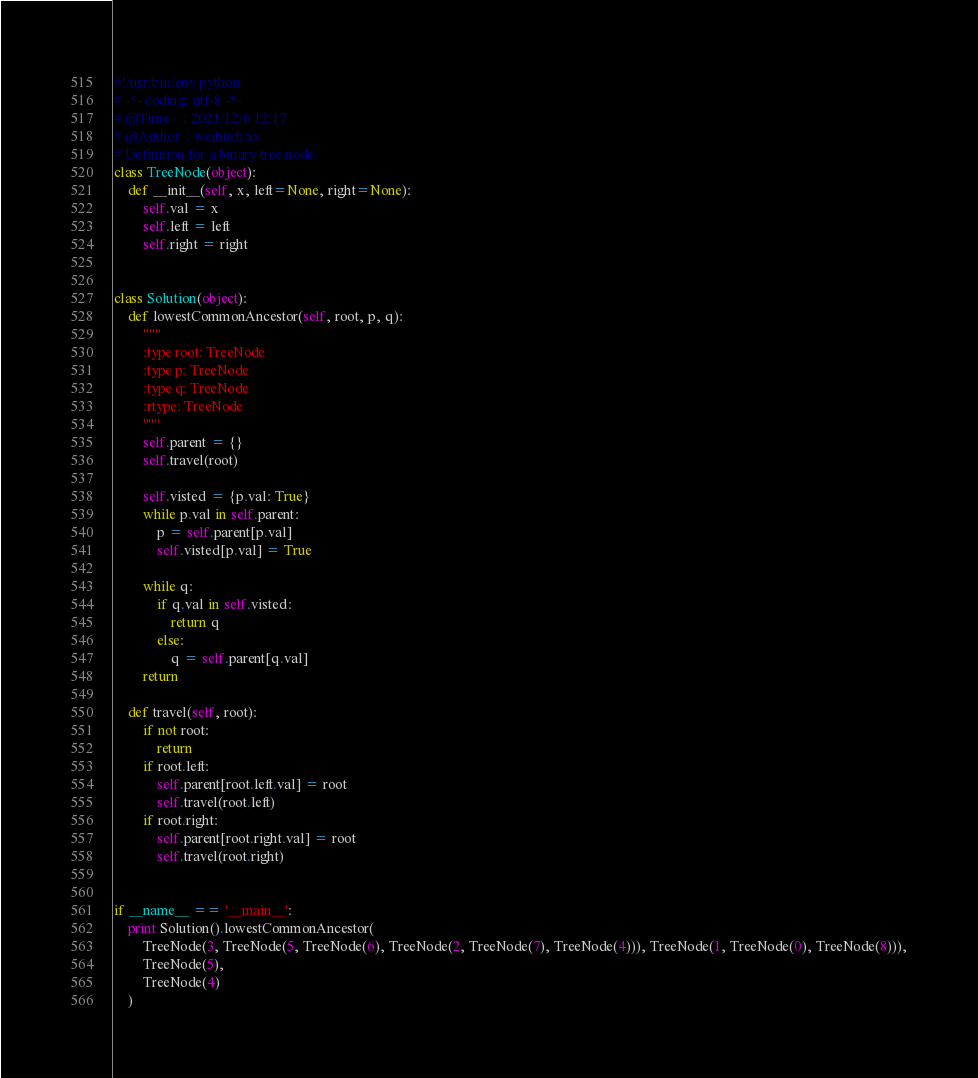Convert code to text. <code><loc_0><loc_0><loc_500><loc_500><_Python_>#!/usr/bin/env python
# -*- coding: utf-8 -*-
# @Time    : 2021/12/6 12:17
# @Author  : weihuchao
# Definition for a binary tree node.
class TreeNode(object):
    def __init__(self, x, left=None, right=None):
        self.val = x
        self.left = left
        self.right = right


class Solution(object):
    def lowestCommonAncestor(self, root, p, q):
        """
        :type root: TreeNode
        :type p: TreeNode
        :type q: TreeNode
        :rtype: TreeNode
        """
        self.parent = {}
        self.travel(root)

        self.visted = {p.val: True}
        while p.val in self.parent:
            p = self.parent[p.val]
            self.visted[p.val] = True

        while q:
            if q.val in self.visted:
                return q
            else:
                q = self.parent[q.val]
        return

    def travel(self, root):
        if not root:
            return
        if root.left:
            self.parent[root.left.val] = root
            self.travel(root.left)
        if root.right:
            self.parent[root.right.val] = root
            self.travel(root.right)


if __name__ == '__main__':
    print Solution().lowestCommonAncestor(
        TreeNode(3, TreeNode(5, TreeNode(6), TreeNode(2, TreeNode(7), TreeNode(4))), TreeNode(1, TreeNode(0), TreeNode(8))),
        TreeNode(5),
        TreeNode(4)
    )
</code> 